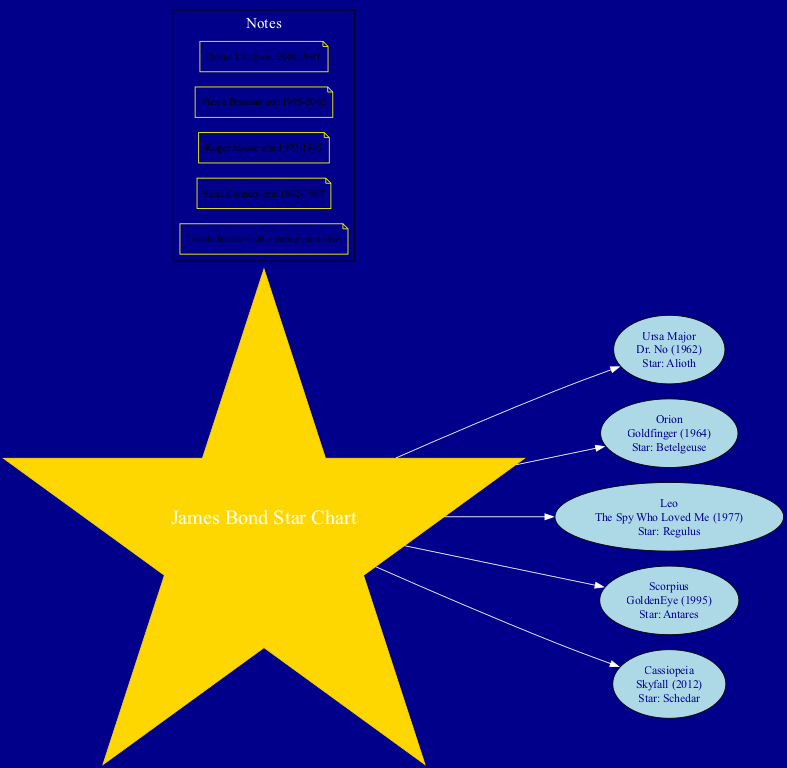What constellation is linked to "Dr. No"? The constellation linked to "Dr. No" is Ursa Major. This information is found directly in the nodes where each constellation is connected to the respective movies.
Answer: Ursa Major How many constellations are represented in the diagram? The diagram features five distinct constellations, as each constellation is illustrated with its own node linked to the center. By counting these nodes, we find that there are five.
Answer: 5 What is the name of the star associated with "GoldenEye"? The star associated with "GoldenEye" is Antares. This can be identified within the node that displays the information of the Scorpius constellation linked to the GoldenEye movie.
Answer: Antares Which movie is represented by the Orion constellation? The movie represented by the Orion constellation is "Goldfinger". This relationship is specified in the node for Orion, which includes the name of the constellation along with the linked movie title.
Answer: Goldfinger What era includes the premiere of "Skyfall"? The era that includes the premiere of "Skyfall" is the Daniel Craig era. This is inferred by the notes section, which outlines the periods of each actor's tenure, with "Skyfall" fitting within the specified dates of Daniel Craig's era.
Answer: Daniel Craig era Which star is noted alongside the "Spy Who Loved Me"? The star noted alongside "The Spy Who Loved Me" is Regulus. This detail is presented clearly in the node for the Leo constellation, which includes both the movie title and its star.
Answer: Regulus In which constellation can the movie "The Spy Who Loved Me" be found? "The Spy Who Loved Me" can be found in the Leo constellation. This information can be located by examining the specific node that associates the movie with its corresponding constellation.
Answer: Leo What color is the center node representing the James Bond star chart? The center node representing the James Bond star chart is gold. This detail can be observed by noting the attributes specified in the diagram's central node, which indicates its color.
Answer: Gold How many stars are mentioned across all constellations? There are five stars mentioned across all constellations, with each of the five constellation nodes listing one corresponding star. Therefore, by counting the stars in each node, we arrive at the total of five.
Answer: 5 